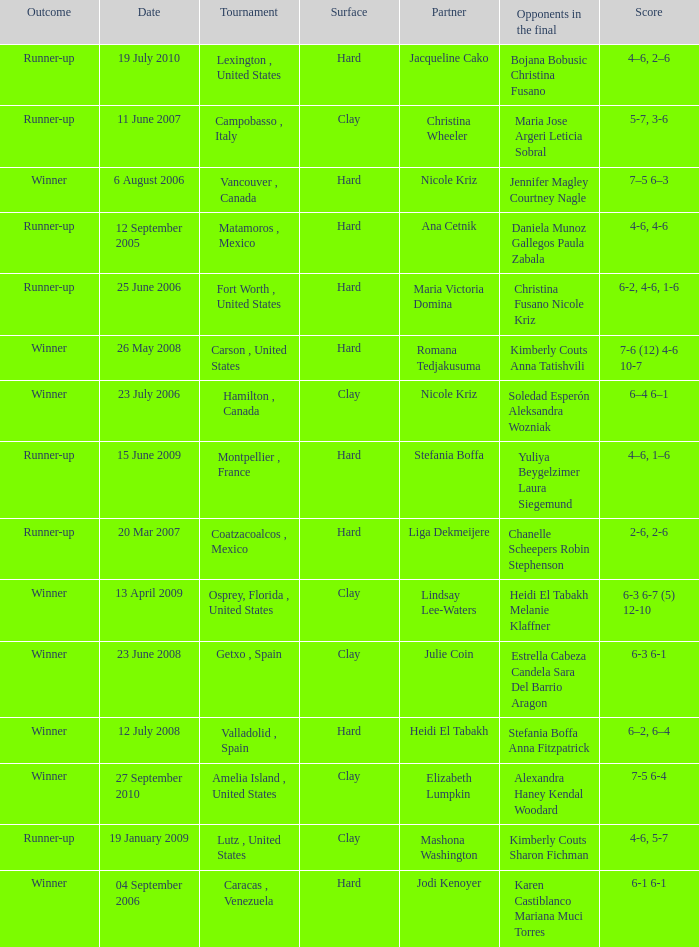Who were the opponents during the final when christina wheeler was partner? Maria Jose Argeri Leticia Sobral. Parse the full table. {'header': ['Outcome', 'Date', 'Tournament', 'Surface', 'Partner', 'Opponents in the final', 'Score'], 'rows': [['Runner-up', '19 July 2010', 'Lexington , United States', 'Hard', 'Jacqueline Cako', 'Bojana Bobusic Christina Fusano', '4–6, 2–6'], ['Runner-up', '11 June 2007', 'Campobasso , Italy', 'Clay', 'Christina Wheeler', 'Maria Jose Argeri Leticia Sobral', '5-7, 3-6'], ['Winner', '6 August 2006', 'Vancouver , Canada', 'Hard', 'Nicole Kriz', 'Jennifer Magley Courtney Nagle', '7–5 6–3'], ['Runner-up', '12 September 2005', 'Matamoros , Mexico', 'Hard', 'Ana Cetnik', 'Daniela Munoz Gallegos Paula Zabala', '4-6, 4-6'], ['Runner-up', '25 June 2006', 'Fort Worth , United States', 'Hard', 'Maria Victoria Domina', 'Christina Fusano Nicole Kriz', '6-2, 4-6, 1-6'], ['Winner', '26 May 2008', 'Carson , United States', 'Hard', 'Romana Tedjakusuma', 'Kimberly Couts Anna Tatishvili', '7-6 (12) 4-6 10-7'], ['Winner', '23 July 2006', 'Hamilton , Canada', 'Clay', 'Nicole Kriz', 'Soledad Esperón Aleksandra Wozniak', '6–4 6–1'], ['Runner-up', '15 June 2009', 'Montpellier , France', 'Hard', 'Stefania Boffa', 'Yuliya Beygelzimer Laura Siegemund', '4–6, 1–6'], ['Runner-up', '20 Mar 2007', 'Coatzacoalcos , Mexico', 'Hard', 'Liga Dekmeijere', 'Chanelle Scheepers Robin Stephenson', '2-6, 2-6'], ['Winner', '13 April 2009', 'Osprey, Florida , United States', 'Clay', 'Lindsay Lee-Waters', 'Heidi El Tabakh Melanie Klaffner', '6-3 6-7 (5) 12-10'], ['Winner', '23 June 2008', 'Getxo , Spain', 'Clay', 'Julie Coin', 'Estrella Cabeza Candela Sara Del Barrio Aragon', '6-3 6-1'], ['Winner', '12 July 2008', 'Valladolid , Spain', 'Hard', 'Heidi El Tabakh', 'Stefania Boffa Anna Fitzpatrick', '6–2, 6–4'], ['Winner', '27 September 2010', 'Amelia Island , United States', 'Clay', 'Elizabeth Lumpkin', 'Alexandra Haney Kendal Woodard', '7-5 6-4'], ['Runner-up', '19 January 2009', 'Lutz , United States', 'Clay', 'Mashona Washington', 'Kimberly Couts Sharon Fichman', '4-6, 5-7'], ['Winner', '04 September 2006', 'Caracas , Venezuela', 'Hard', 'Jodi Kenoyer', 'Karen Castiblanco Mariana Muci Torres', '6-1 6-1']]} 